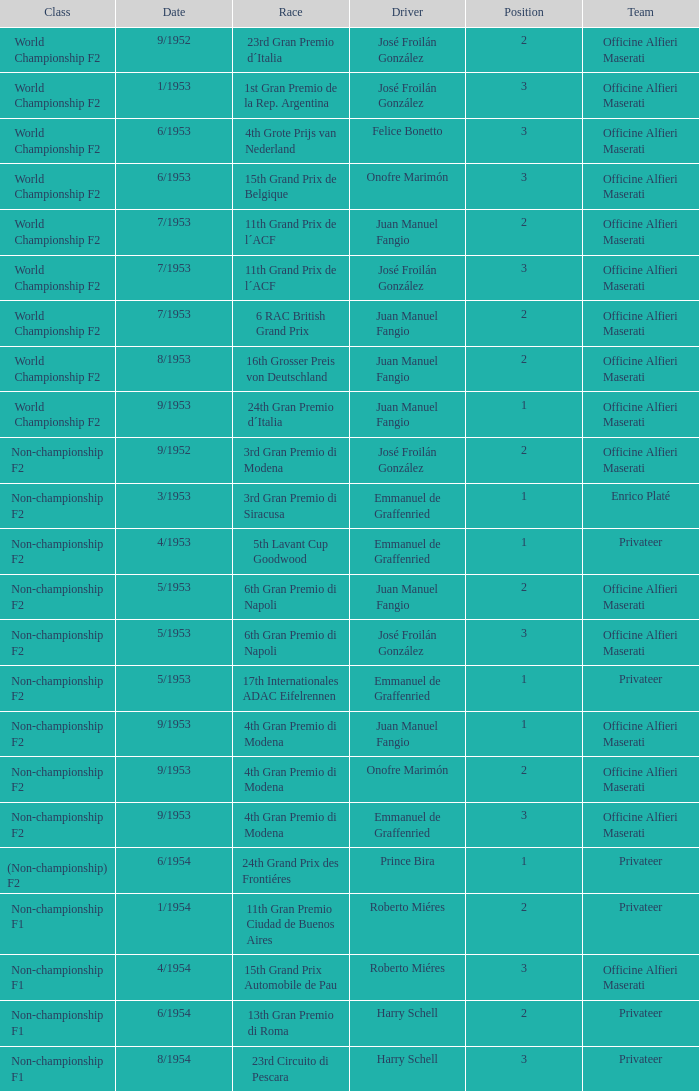What driver is associated with the officine alfieri maserati team, belongs to the non-championship f2 class, has a ranking of 2, and a date of 9/1952? José Froilán González. 